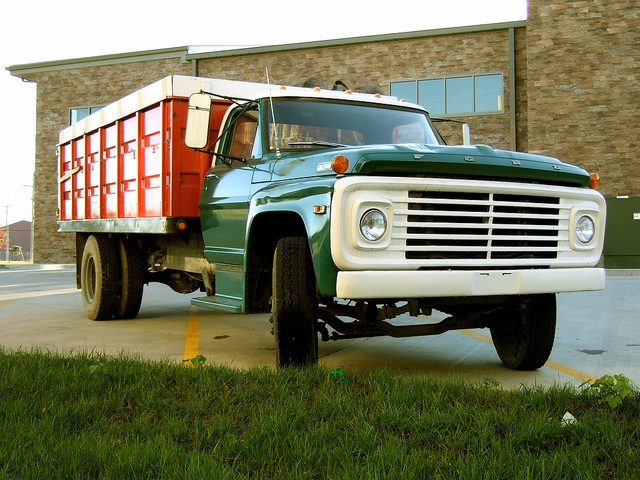Describe the objects in this image and their specific colors. I can see a truck in white, black, teal, and darkgray tones in this image. 